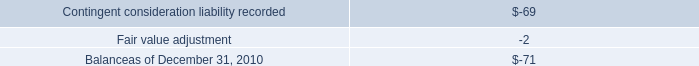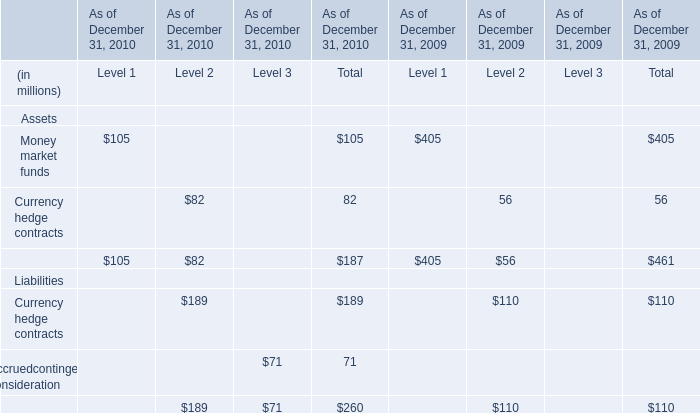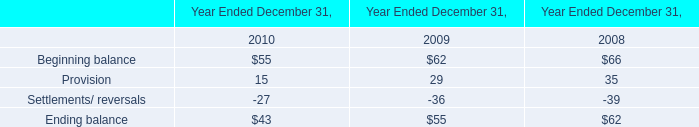What's the difference of Total of Currency hedge contracts between 2010 and 2009? (in million) 
Computations: (189 - 110)
Answer: 79.0. 